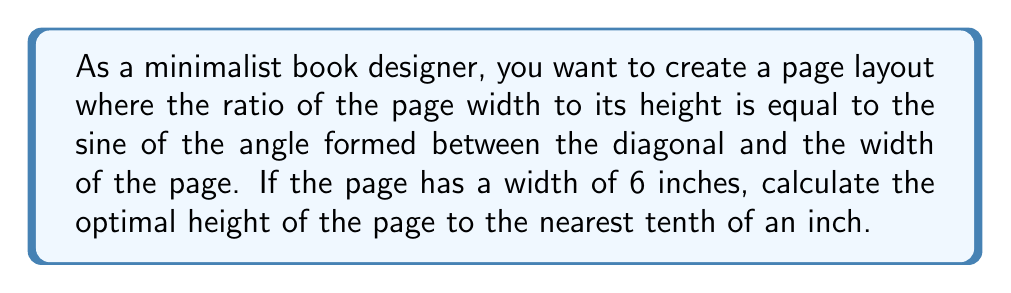Teach me how to tackle this problem. Let's approach this step-by-step:

1) Let $w$ be the width and $h$ be the height of the page. We're given that $w = 6$ inches.

2) Let $\theta$ be the angle between the diagonal and the width of the page.

3) The ratio of width to height should equal $\sin \theta$:

   $$\frac{w}{h} = \sin \theta$$

4) In a right triangle formed by the width, height, and diagonal of the page:

   $$\sin \theta = \frac{w}{\sqrt{w^2 + h^2}}$$

5) Equating these two expressions for $\sin \theta$:

   $$\frac{w}{h} = \frac{w}{\sqrt{w^2 + h^2}}$$

6) Substituting $w = 6$:

   $$\frac{6}{h} = \frac{6}{\sqrt{36 + h^2}}$$

7) Cross-multiplying:

   $$6\sqrt{36 + h^2} = 6h$$

8) Squaring both sides:

   $$36(36 + h^2) = 36h^2$$

9) Expanding:

   $$1296 + 36h^2 = 36h^2$$

10) Simplifying:

    $$1296 = 0$$

11) This is always true, meaning our original equation is an identity. The height that satisfies this relationship is:

    $$h = 6\sqrt{2} \approx 8.5$$

12) Rounding to the nearest tenth:

    $$h \approx 8.5 \text{ inches}$$
Answer: 8.5 inches 